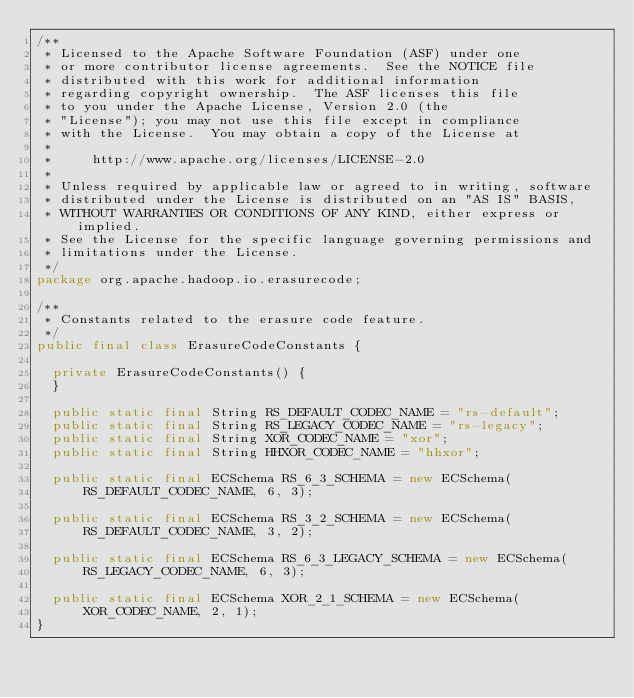Convert code to text. <code><loc_0><loc_0><loc_500><loc_500><_Java_>/**
 * Licensed to the Apache Software Foundation (ASF) under one
 * or more contributor license agreements.  See the NOTICE file
 * distributed with this work for additional information
 * regarding copyright ownership.  The ASF licenses this file
 * to you under the Apache License, Version 2.0 (the
 * "License"); you may not use this file except in compliance
 * with the License.  You may obtain a copy of the License at
 *
 *     http://www.apache.org/licenses/LICENSE-2.0
 *
 * Unless required by applicable law or agreed to in writing, software
 * distributed under the License is distributed on an "AS IS" BASIS,
 * WITHOUT WARRANTIES OR CONDITIONS OF ANY KIND, either express or implied.
 * See the License for the specific language governing permissions and
 * limitations under the License.
 */
package org.apache.hadoop.io.erasurecode;

/**
 * Constants related to the erasure code feature.
 */
public final class ErasureCodeConstants {

  private ErasureCodeConstants() {
  }

  public static final String RS_DEFAULT_CODEC_NAME = "rs-default";
  public static final String RS_LEGACY_CODEC_NAME = "rs-legacy";
  public static final String XOR_CODEC_NAME = "xor";
  public static final String HHXOR_CODEC_NAME = "hhxor";

  public static final ECSchema RS_6_3_SCHEMA = new ECSchema(
      RS_DEFAULT_CODEC_NAME, 6, 3);

  public static final ECSchema RS_3_2_SCHEMA = new ECSchema(
      RS_DEFAULT_CODEC_NAME, 3, 2);

  public static final ECSchema RS_6_3_LEGACY_SCHEMA = new ECSchema(
      RS_LEGACY_CODEC_NAME, 6, 3);

  public static final ECSchema XOR_2_1_SCHEMA = new ECSchema(
      XOR_CODEC_NAME, 2, 1);
}
</code> 